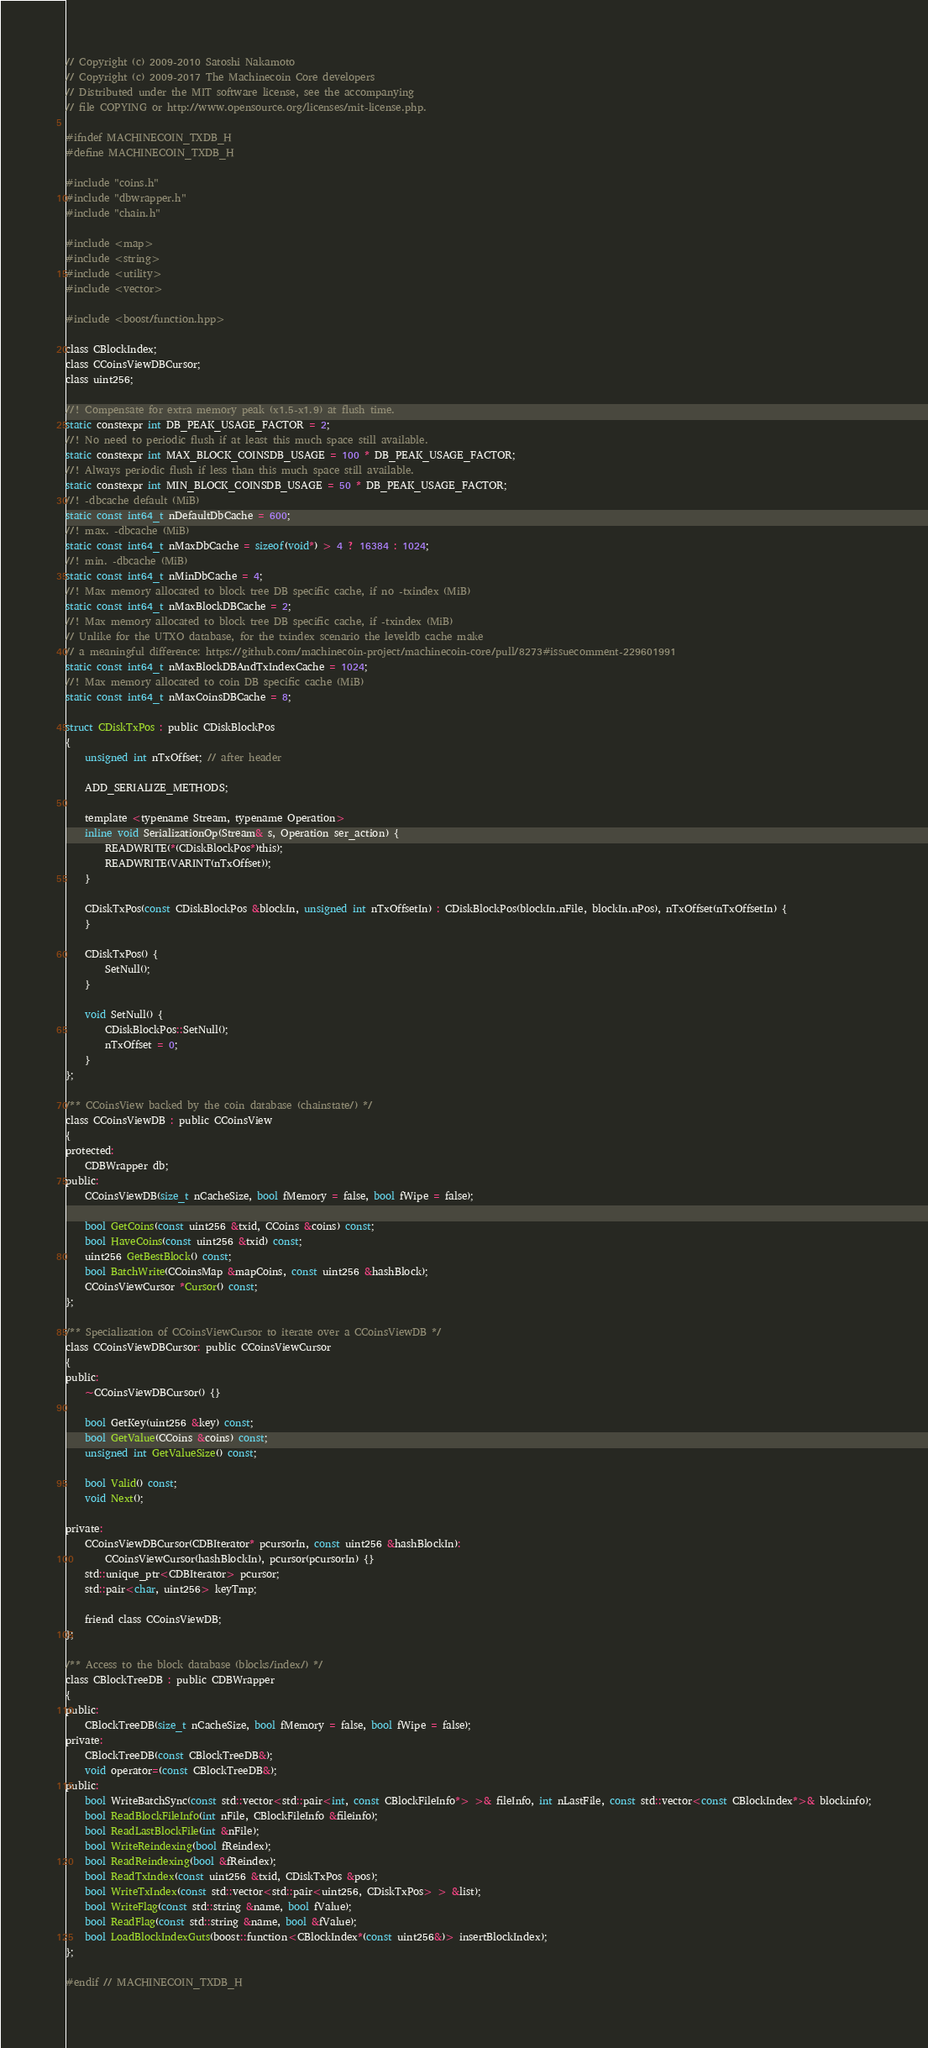Convert code to text. <code><loc_0><loc_0><loc_500><loc_500><_C_>// Copyright (c) 2009-2010 Satoshi Nakamoto
// Copyright (c) 2009-2017 The Machinecoin Core developers
// Distributed under the MIT software license, see the accompanying
// file COPYING or http://www.opensource.org/licenses/mit-license.php.

#ifndef MACHINECOIN_TXDB_H
#define MACHINECOIN_TXDB_H

#include "coins.h"
#include "dbwrapper.h"
#include "chain.h"

#include <map>
#include <string>
#include <utility>
#include <vector>

#include <boost/function.hpp>

class CBlockIndex;
class CCoinsViewDBCursor;
class uint256;

//! Compensate for extra memory peak (x1.5-x1.9) at flush time.
static constexpr int DB_PEAK_USAGE_FACTOR = 2;
//! No need to periodic flush if at least this much space still available.
static constexpr int MAX_BLOCK_COINSDB_USAGE = 100 * DB_PEAK_USAGE_FACTOR;
//! Always periodic flush if less than this much space still available.
static constexpr int MIN_BLOCK_COINSDB_USAGE = 50 * DB_PEAK_USAGE_FACTOR;
//! -dbcache default (MiB)
static const int64_t nDefaultDbCache = 600;
//! max. -dbcache (MiB)
static const int64_t nMaxDbCache = sizeof(void*) > 4 ? 16384 : 1024;
//! min. -dbcache (MiB)
static const int64_t nMinDbCache = 4;
//! Max memory allocated to block tree DB specific cache, if no -txindex (MiB)
static const int64_t nMaxBlockDBCache = 2;
//! Max memory allocated to block tree DB specific cache, if -txindex (MiB)
// Unlike for the UTXO database, for the txindex scenario the leveldb cache make
// a meaningful difference: https://github.com/machinecoin-project/machinecoin-core/pull/8273#issuecomment-229601991
static const int64_t nMaxBlockDBAndTxIndexCache = 1024;
//! Max memory allocated to coin DB specific cache (MiB)
static const int64_t nMaxCoinsDBCache = 8;

struct CDiskTxPos : public CDiskBlockPos
{
    unsigned int nTxOffset; // after header

    ADD_SERIALIZE_METHODS;

    template <typename Stream, typename Operation>
    inline void SerializationOp(Stream& s, Operation ser_action) {
        READWRITE(*(CDiskBlockPos*)this);
        READWRITE(VARINT(nTxOffset));
    }

    CDiskTxPos(const CDiskBlockPos &blockIn, unsigned int nTxOffsetIn) : CDiskBlockPos(blockIn.nFile, blockIn.nPos), nTxOffset(nTxOffsetIn) {
    }

    CDiskTxPos() {
        SetNull();
    }

    void SetNull() {
        CDiskBlockPos::SetNull();
        nTxOffset = 0;
    }
};

/** CCoinsView backed by the coin database (chainstate/) */
class CCoinsViewDB : public CCoinsView
{
protected:
    CDBWrapper db;
public:
    CCoinsViewDB(size_t nCacheSize, bool fMemory = false, bool fWipe = false);

    bool GetCoins(const uint256 &txid, CCoins &coins) const;
    bool HaveCoins(const uint256 &txid) const;
    uint256 GetBestBlock() const;
    bool BatchWrite(CCoinsMap &mapCoins, const uint256 &hashBlock);
    CCoinsViewCursor *Cursor() const;
};

/** Specialization of CCoinsViewCursor to iterate over a CCoinsViewDB */
class CCoinsViewDBCursor: public CCoinsViewCursor
{
public:
    ~CCoinsViewDBCursor() {}

    bool GetKey(uint256 &key) const;
    bool GetValue(CCoins &coins) const;
    unsigned int GetValueSize() const;

    bool Valid() const;
    void Next();

private:
    CCoinsViewDBCursor(CDBIterator* pcursorIn, const uint256 &hashBlockIn):
        CCoinsViewCursor(hashBlockIn), pcursor(pcursorIn) {}
    std::unique_ptr<CDBIterator> pcursor;
    std::pair<char, uint256> keyTmp;

    friend class CCoinsViewDB;
};

/** Access to the block database (blocks/index/) */
class CBlockTreeDB : public CDBWrapper
{
public:
    CBlockTreeDB(size_t nCacheSize, bool fMemory = false, bool fWipe = false);
private:
    CBlockTreeDB(const CBlockTreeDB&);
    void operator=(const CBlockTreeDB&);
public:
    bool WriteBatchSync(const std::vector<std::pair<int, const CBlockFileInfo*> >& fileInfo, int nLastFile, const std::vector<const CBlockIndex*>& blockinfo);
    bool ReadBlockFileInfo(int nFile, CBlockFileInfo &fileinfo);
    bool ReadLastBlockFile(int &nFile);
    bool WriteReindexing(bool fReindex);
    bool ReadReindexing(bool &fReindex);
    bool ReadTxIndex(const uint256 &txid, CDiskTxPos &pos);
    bool WriteTxIndex(const std::vector<std::pair<uint256, CDiskTxPos> > &list);
    bool WriteFlag(const std::string &name, bool fValue);
    bool ReadFlag(const std::string &name, bool &fValue);
    bool LoadBlockIndexGuts(boost::function<CBlockIndex*(const uint256&)> insertBlockIndex);
};

#endif // MACHINECOIN_TXDB_H
</code> 